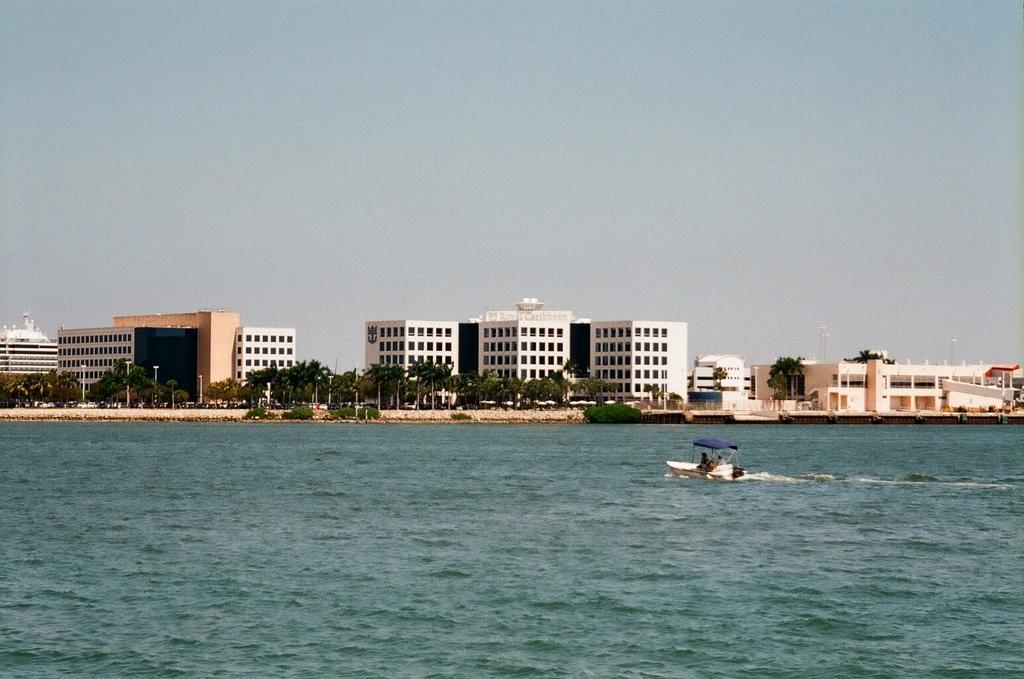How would you summarize this image in a sentence or two? This image consists of a boat in the water, fence, trees, light poles, vehicles on the road, buildings and the sky. This image is taken may be near the ocean. 